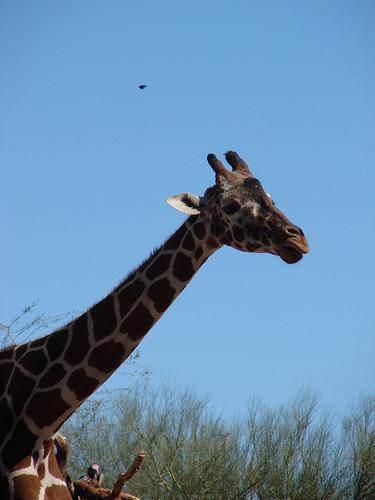How many giraffes are in the photo?
Give a very brief answer. 1. 